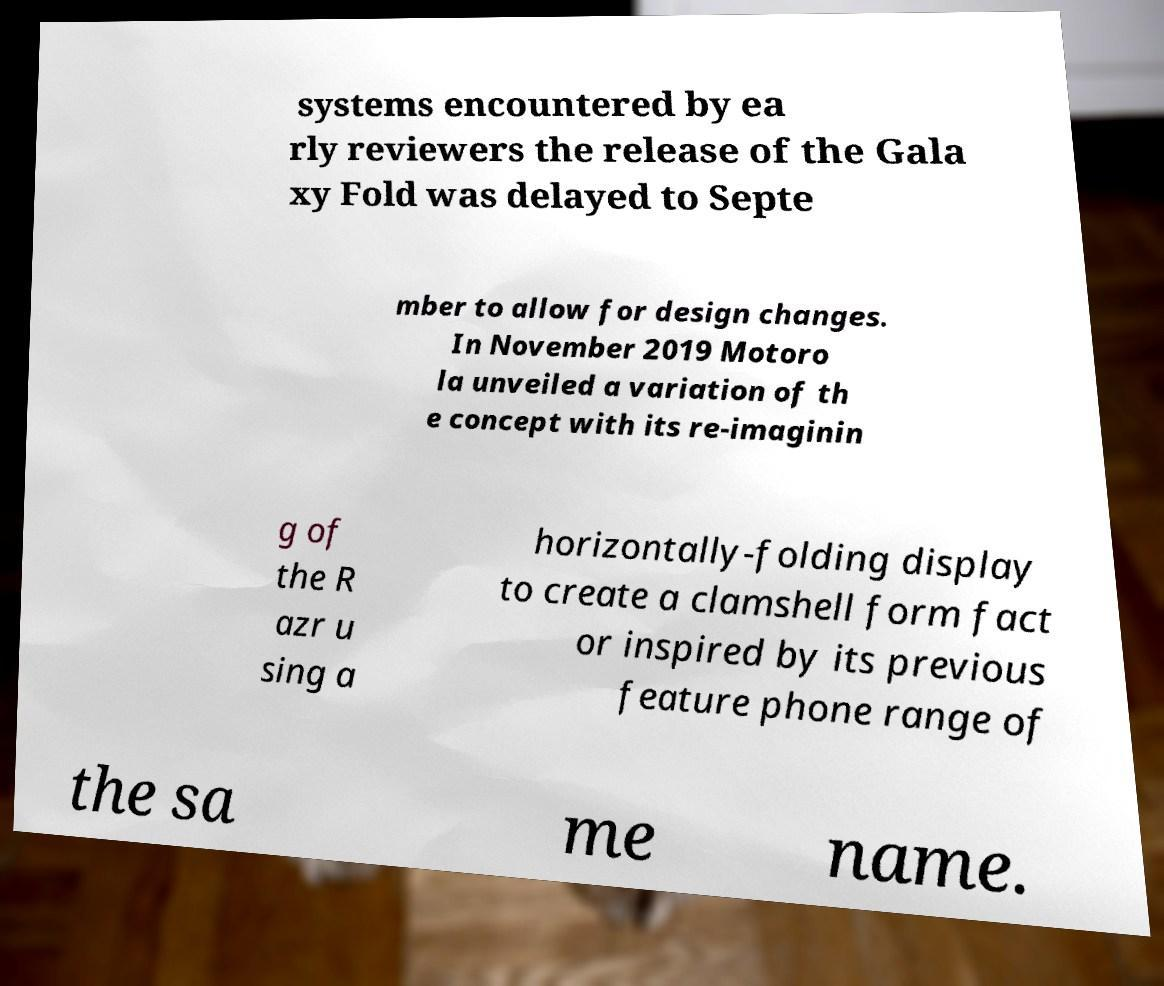I need the written content from this picture converted into text. Can you do that? systems encountered by ea rly reviewers the release of the Gala xy Fold was delayed to Septe mber to allow for design changes. In November 2019 Motoro la unveiled a variation of th e concept with its re-imaginin g of the R azr u sing a horizontally-folding display to create a clamshell form fact or inspired by its previous feature phone range of the sa me name. 